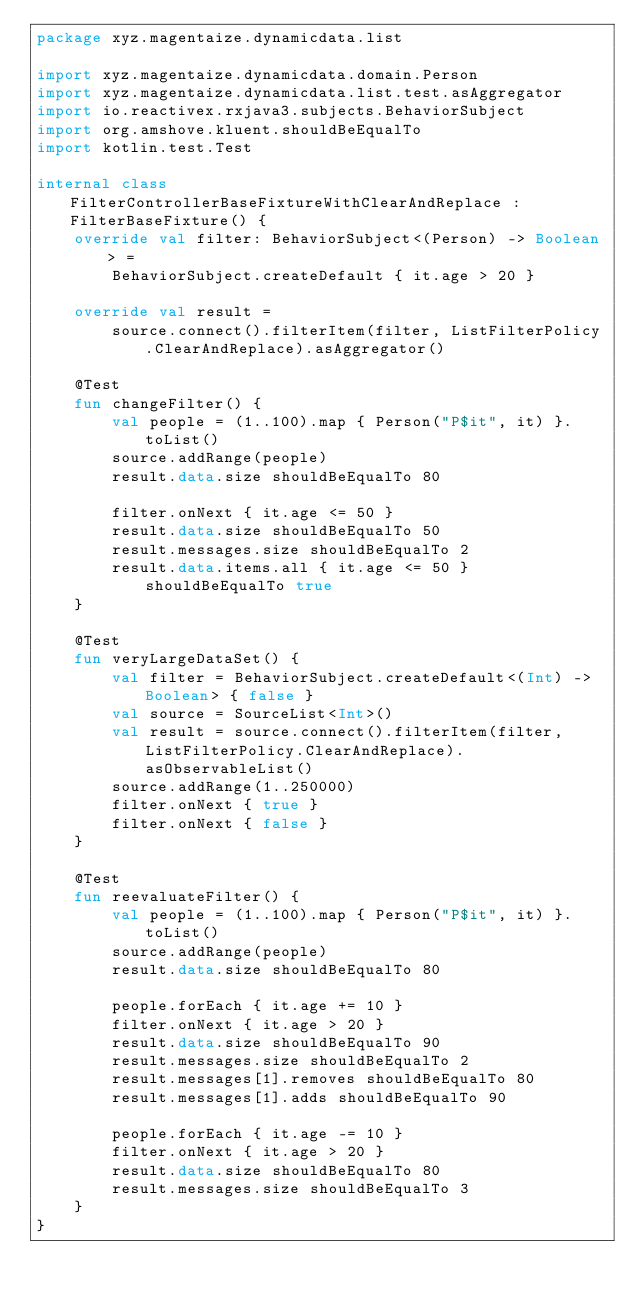<code> <loc_0><loc_0><loc_500><loc_500><_Kotlin_>package xyz.magentaize.dynamicdata.list

import xyz.magentaize.dynamicdata.domain.Person
import xyz.magentaize.dynamicdata.list.test.asAggregator
import io.reactivex.rxjava3.subjects.BehaviorSubject
import org.amshove.kluent.shouldBeEqualTo
import kotlin.test.Test

internal class FilterControllerBaseFixtureWithClearAndReplace : FilterBaseFixture() {
    override val filter: BehaviorSubject<(Person) -> Boolean> =
        BehaviorSubject.createDefault { it.age > 20 }

    override val result =
        source.connect().filterItem(filter, ListFilterPolicy.ClearAndReplace).asAggregator()

    @Test
    fun changeFilter() {
        val people = (1..100).map { Person("P$it", it) }.toList()
        source.addRange(people)
        result.data.size shouldBeEqualTo 80

        filter.onNext { it.age <= 50 }
        result.data.size shouldBeEqualTo 50
        result.messages.size shouldBeEqualTo 2
        result.data.items.all { it.age <= 50 } shouldBeEqualTo true
    }

    @Test
    fun veryLargeDataSet() {
        val filter = BehaviorSubject.createDefault<(Int) -> Boolean> { false }
        val source = SourceList<Int>()
        val result = source.connect().filterItem(filter, ListFilterPolicy.ClearAndReplace).asObservableList()
        source.addRange(1..250000)
        filter.onNext { true }
        filter.onNext { false }
    }

    @Test
    fun reevaluateFilter() {
        val people = (1..100).map { Person("P$it", it) }.toList()
        source.addRange(people)
        result.data.size shouldBeEqualTo 80

        people.forEach { it.age += 10 }
        filter.onNext { it.age > 20 }
        result.data.size shouldBeEqualTo 90
        result.messages.size shouldBeEqualTo 2
        result.messages[1].removes shouldBeEqualTo 80
        result.messages[1].adds shouldBeEqualTo 90

        people.forEach { it.age -= 10 }
        filter.onNext { it.age > 20 }
        result.data.size shouldBeEqualTo 80
        result.messages.size shouldBeEqualTo 3
    }
}
</code> 